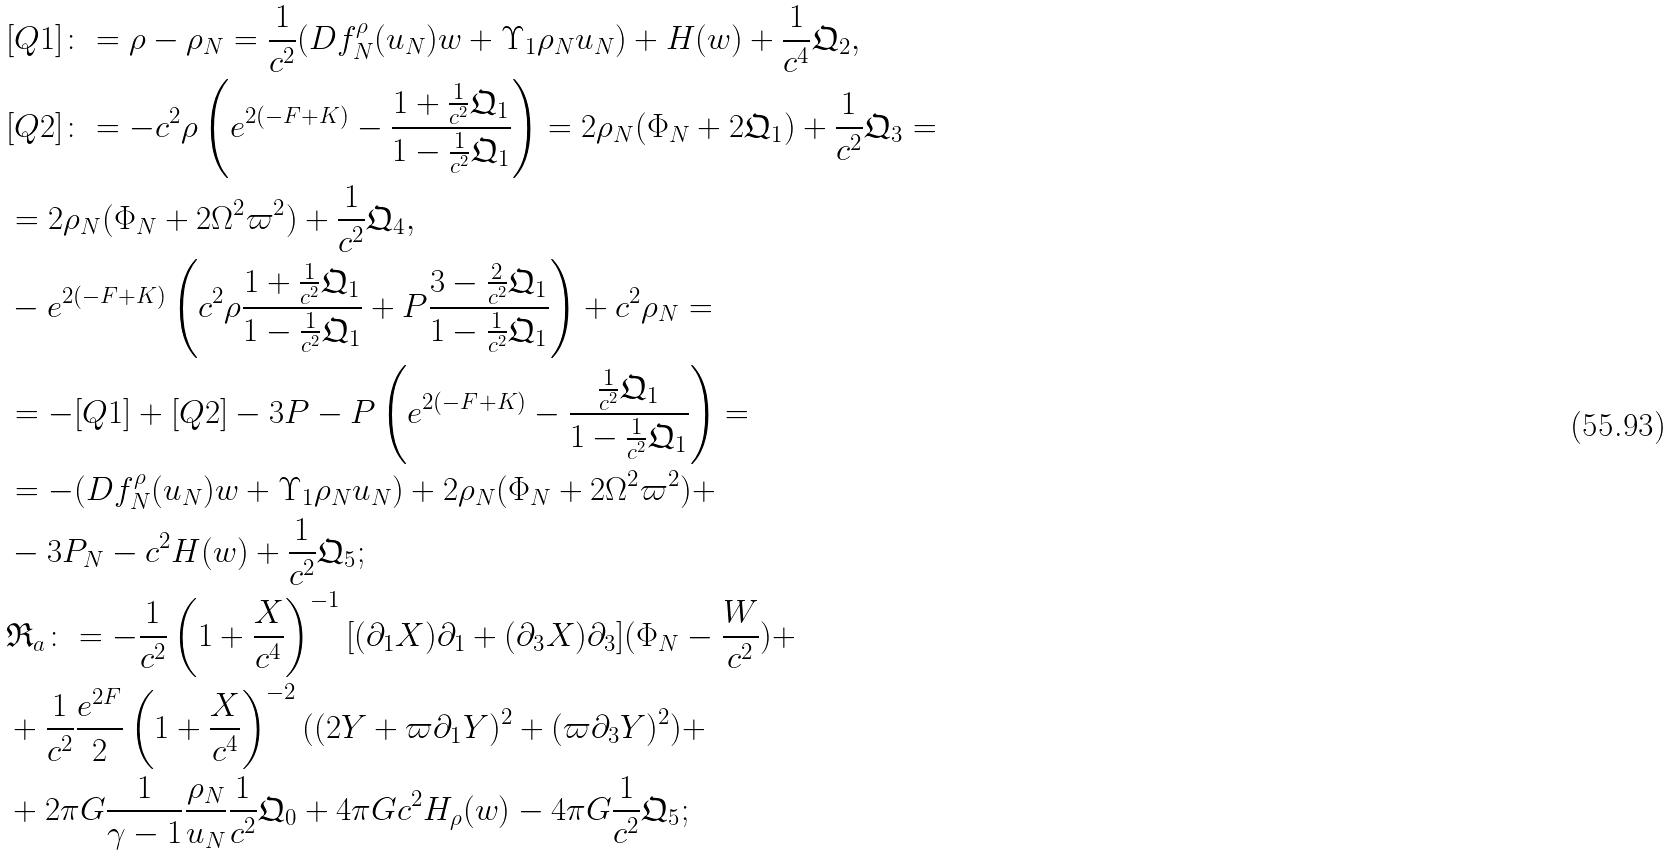<formula> <loc_0><loc_0><loc_500><loc_500>& [ Q 1 ] \colon = \rho - \rho _ { N } = \frac { 1 } { c ^ { 2 } } ( D f _ { N } ^ { \rho } ( u _ { N } ) w + \Upsilon _ { 1 } \rho _ { N } u _ { N } ) + H ( w ) + \frac { 1 } { c ^ { 4 } } \mathfrak { Q } _ { 2 } , \\ & [ Q 2 ] \colon = - c ^ { 2 } \rho \left ( e ^ { 2 ( - F + K ) } - \frac { 1 + \frac { 1 } { c ^ { 2 } } \mathfrak { Q } _ { 1 } } { 1 - \frac { 1 } { c ^ { 2 } } \mathfrak { Q } _ { 1 } } \right ) = 2 \rho _ { N } ( \Phi _ { N } + 2 \mathfrak { Q } _ { 1 } ) + \frac { 1 } { c ^ { 2 } } \mathfrak { Q } _ { 3 } = \\ & = 2 \rho _ { N } ( \Phi _ { N } + 2 \Omega ^ { 2 } \varpi ^ { 2 } ) + \frac { 1 } { c ^ { 2 } } \mathfrak { Q } _ { 4 } , \\ & - e ^ { 2 ( - F + K ) } \left ( c ^ { 2 } \rho \frac { 1 + \frac { 1 } { c ^ { 2 } } \mathfrak { Q } _ { 1 } } { 1 - \frac { 1 } { c ^ { 2 } } \mathfrak { Q } _ { 1 } } + P \frac { 3 - \frac { 2 } { c ^ { 2 } } \mathfrak { Q } _ { 1 } } { 1 - \frac { 1 } { c ^ { 2 } } \mathfrak { Q } _ { 1 } } \right ) + c ^ { 2 } \rho _ { N } = \\ & = - [ Q 1 ] + [ Q 2 ] - 3 P - P \left ( e ^ { 2 ( - F + K ) } - \frac { \frac { 1 } { c ^ { 2 } } \mathfrak { Q } _ { 1 } } { 1 - \frac { 1 } { c ^ { 2 } } \mathfrak { Q } _ { 1 } } \right ) = \\ & = - ( D f _ { N } ^ { \rho } ( u _ { N } ) w + \Upsilon _ { 1 } \rho _ { N } u _ { N } ) + 2 \rho _ { N } ( \Phi _ { N } + 2 \Omega ^ { 2 } \varpi ^ { 2 } ) + \\ & - 3 P _ { N } - c ^ { 2 } H ( w ) + \frac { 1 } { c ^ { 2 } } \mathfrak { Q } _ { 5 } ; \\ & \mathfrak { R } _ { a } \colon = - \frac { 1 } { c ^ { 2 } } \left ( 1 + \frac { X } { c ^ { 4 } } \right ) ^ { - 1 } [ ( \partial _ { 1 } X ) \partial _ { 1 } + ( \partial _ { 3 } X ) \partial _ { 3 } ] ( \Phi _ { N } - \frac { W } { c ^ { 2 } } ) + \\ & + \frac { 1 } { c ^ { 2 } } \frac { e ^ { 2 F } } { 2 } \left ( 1 + \frac { X } { c ^ { 4 } } \right ) ^ { - 2 } ( ( 2 Y + \varpi \partial _ { 1 } Y ) ^ { 2 } + ( \varpi \partial _ { 3 } Y ) ^ { 2 } ) + \\ & + 2 \pi G \frac { 1 } { \gamma - 1 } \frac { \rho _ { N } } { u _ { N } } \frac { 1 } { c ^ { 2 } } \mathfrak { Q } _ { 0 } + 4 \pi G c ^ { 2 } H _ { \rho } ( w ) - 4 \pi G \frac { 1 } { c ^ { 2 } } \mathfrak { Q } _ { 5 } ;</formula> 